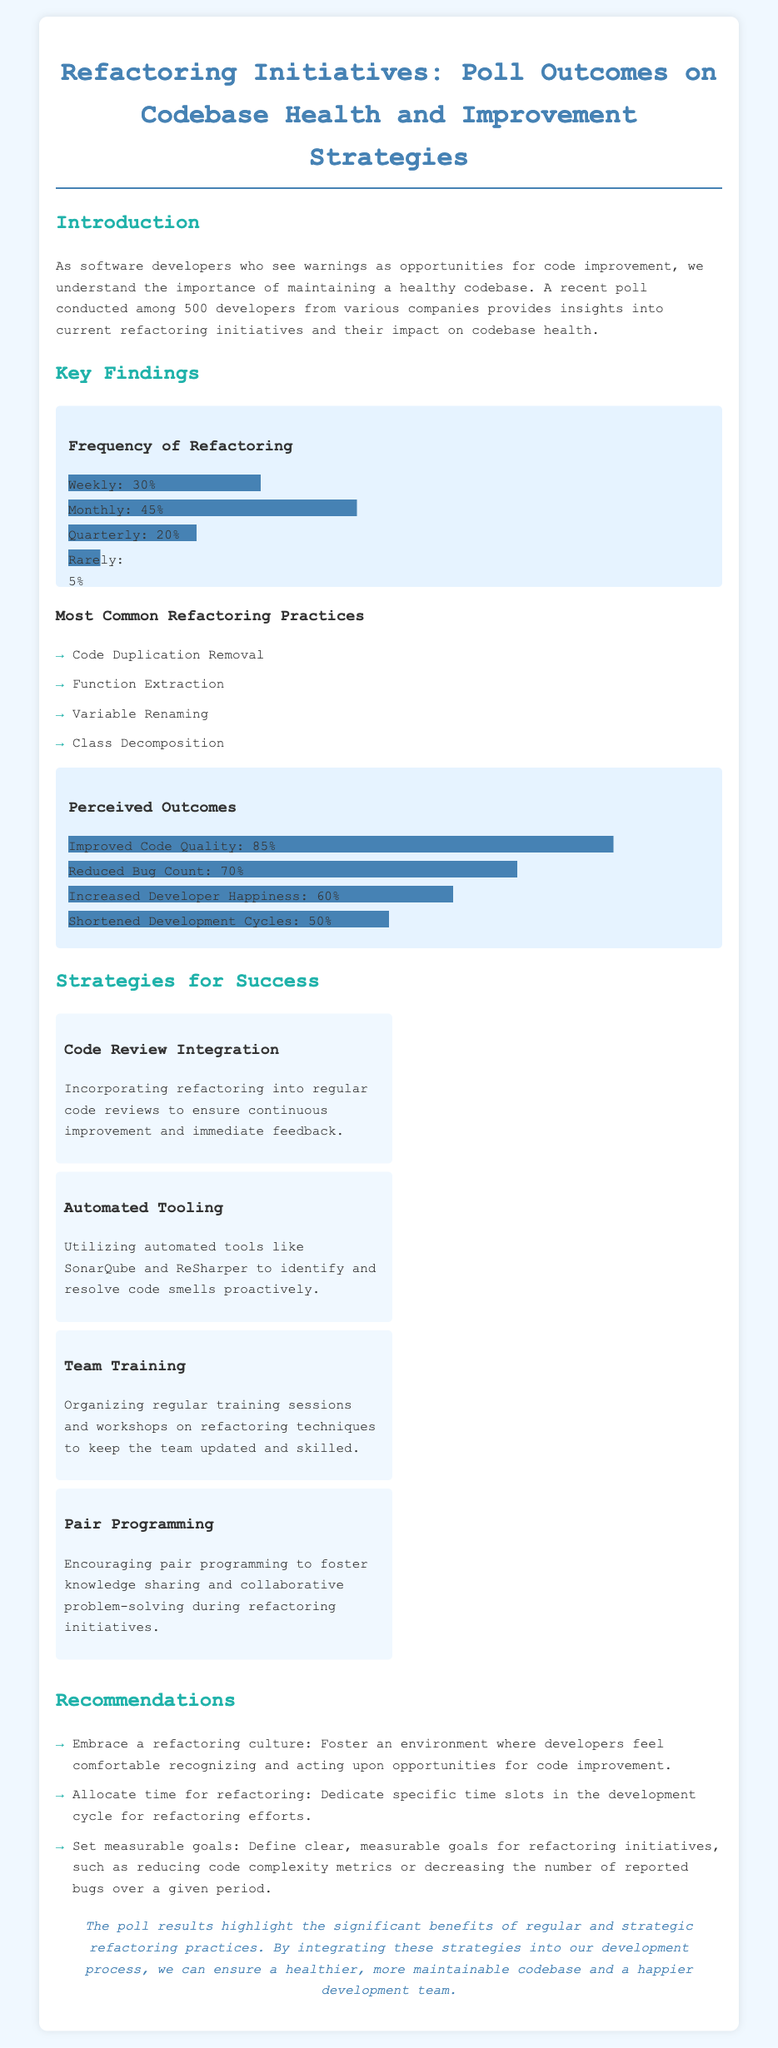What percentage of developers refactor weekly? The document states that 30% of developers refactor weekly.
Answer: 30% What are the most common refactoring practices? The document lists four common practices, including "Code Duplication Removal."
Answer: Code Duplication Removal What is the perceived outcome for improved code quality? The document indicates that 85% of developers perceive improved code quality as an outcome of refactoring.
Answer: 85% What strategy involves using tools like SonarQube? The document mentions "Automated Tooling" as a strategy that involves using such tools.
Answer: Automated Tooling How often do developers report reduced bug count as an outcome? The document states that 70% of developers report a reduced bug count as a result of refactoring.
Answer: 70% What percentage of developers refactor quarterly? The document specifies that 20% of developers refactor quarterly.
Answer: 20% What is one of the recommendations regarding refactoring culture? The document recommends fostering an environment where developers feel comfortable recognizing opportunities for improvement.
Answer: Embrace a refactoring culture What is the conclusion about the benefits of refactoring practices? The document concludes that the poll results highlight significant benefits of regular and strategic refactoring practices.
Answer: Significant benefits 